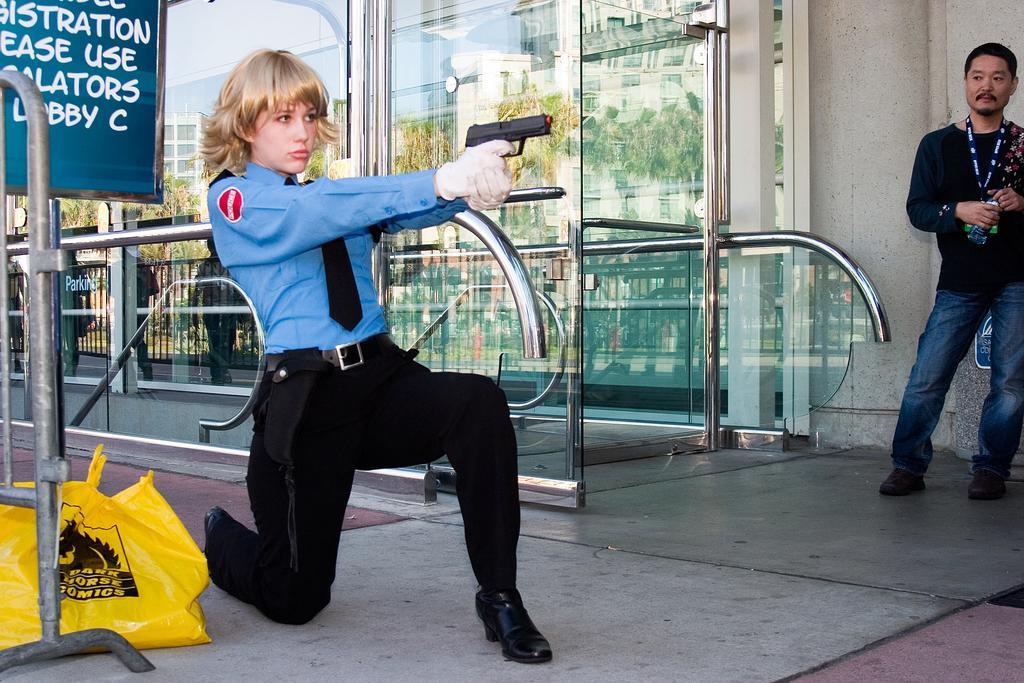Can you describe this image briefly? This image is taken outdoors. At the bottom of the image there is a floor. On the right side of the image a man is standing on the floor and he is holding a bottle in his hands. On the left side of the image there is a railing and there is a board with a text on it and there is a cover on the floor. A woman is sitting on her knees and she is holding a gun in her hands. In the background there is a wall with a few glass doors. There are a few railings. 